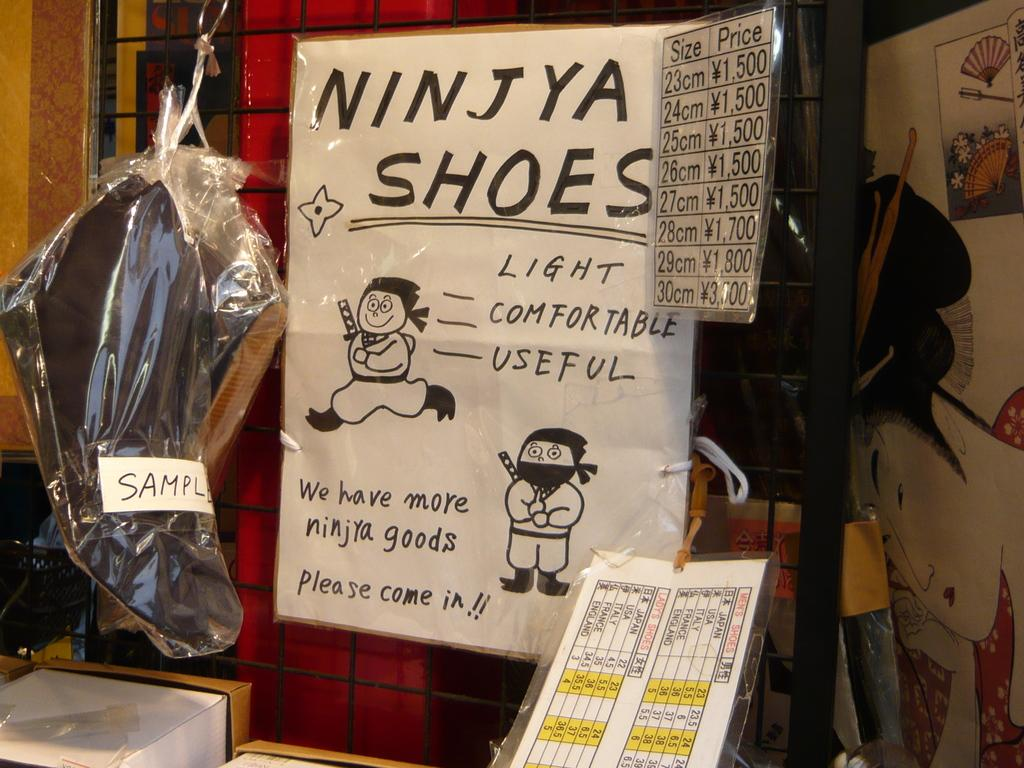<image>
Provide a brief description of the given image. A handmade sign in a store advertises NINJYA SHOES. 